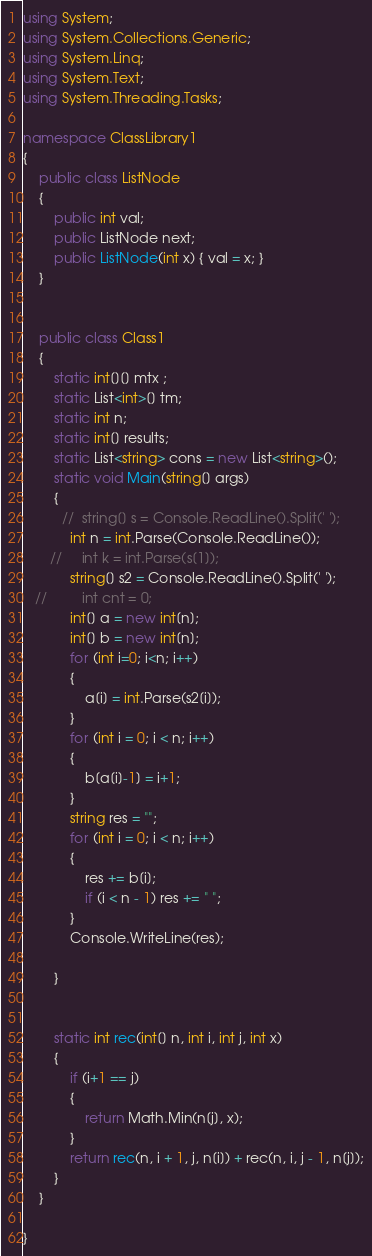Convert code to text. <code><loc_0><loc_0><loc_500><loc_500><_C#_>using System;
using System.Collections.Generic;
using System.Linq;
using System.Text;
using System.Threading.Tasks;

namespace ClassLibrary1
{
    public class ListNode
    {
        public int val;
        public ListNode next;
        public ListNode(int x) { val = x; }
    }


    public class Class1
    {
        static int[][] mtx ;
        static List<int>[] tm;
        static int n;
        static int[] results;
        static List<string> cons = new List<string>();
        static void Main(string[] args)
        {
          //  string[] s = Console.ReadLine().Split(' ');
            int n = int.Parse(Console.ReadLine());
       //     int k = int.Parse(s[1]);
            string[] s2 = Console.ReadLine().Split(' ');
   //         int cnt = 0;
            int[] a = new int[n];
            int[] b = new int[n];
            for (int i=0; i<n; i++)
            {
                a[i] = int.Parse(s2[i]);
            }
            for (int i = 0; i < n; i++)
            {
                b[a[i]-1] = i+1;
            }
            string res = "";
            for (int i = 0; i < n; i++)
            {
                res += b[i];
                if (i < n - 1) res += " ";
            }
            Console.WriteLine(res);

        }


        static int rec(int[] n, int i, int j, int x)
        {
            if (i+1 == j)
            {
                return Math.Min(n[j], x);
            }
            return rec(n, i + 1, j, n[i]) + rec(n, i, j - 1, n[j]);
        }
    }

}</code> 